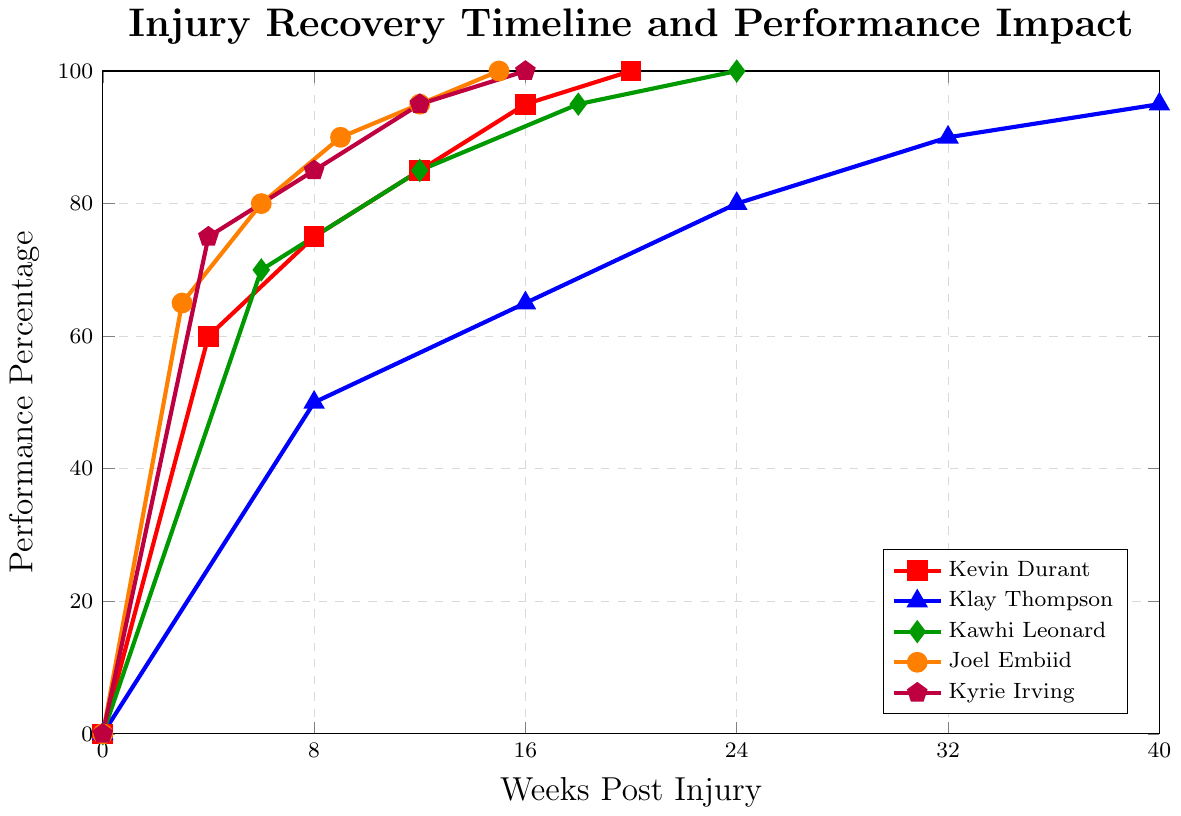What's the maximum performance percentage that Kevin Durant reaches post-injury, and at which week does he achieve it? To answer this, look at Kevin Durant's data points on the chart. The maximum performance percentage for Kevin Durant is 100%, which he achieves in the 20th week post-injury.
Answer: 100%, 20th week Compare the performance percentages of Kyrie Irving and Klay Thompson at the 8th week post-injury. Who has the higher performance percentage and by how much? At the 8th week post-injury, Kyrie Irving has a performance percentage of 85%, whereas Klay Thompson has 50%. Kyrie Irving's performance percentage is higher than Klay Thompson's by (85 - 50) = 35%.
Answer: Kyrie Irving by 35% What's the average performance percentage of Joel Embiid between weeks 3 and 12 post-injury? To find the average, sum up Joel Embiid's performance percentages at weeks 3, 6, 9, and 12 (65 + 80 + 90 + 95) and then divide by the number of data points, which is 4. So, (65 + 80 + 90 + 95) / 4 = 82.5.
Answer: 82.5% At the 16th week post-injury, which player has the lowest performance percentage and what is it? At the 16th week post-injury, the chart shows performance percentages as follows: Kevin Durant 95%, Klay Thompson 65%, Kawhi Leonard does not have an entry, Joel Embiid reaches 100%, and Kyrie Irving 95%. Klay Thompson has the lowest performance percentage at 65%.
Answer: Klay Thompson, 65% How many weeks does it take for Kawhi Leonard and Kevin Durant to both reach a performance percentage of 95%? According to the chart, Kevin Durant reaches a performance percentage of 95% in the 16th week post-injury, while Kawhi Leonard reaches 95% in the 18th week post-injury.
Answer: Kevin Durant 16 weeks, Kawhi Leonard 18 weeks From the figure, identify which player shows the steepest initial increase in performance percentage and in which weeks this occurs? The steepest initial increase is observed by calculating the rate of change in performance percentage over time. Joel Embiid shows the steepest initial increase with a 65% increase over 3 weeks (from 0% to 65%), resulting in approximately 21.67% increase per week.
Answer: Joel Embiid, 0 to 3 weeks 